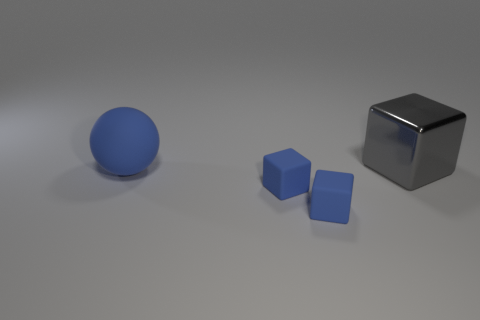Can you tell me what the lighting in the scene suggests about the placement of the objects? Certainly, the lighting in the scene creates subtle shadows that suggest the objects are resting on a flat surface. The direction of the shadows indicates a light source coming from the upper right, illuminating the objects asymmetrically and accentuating their three-dimensional forms. 